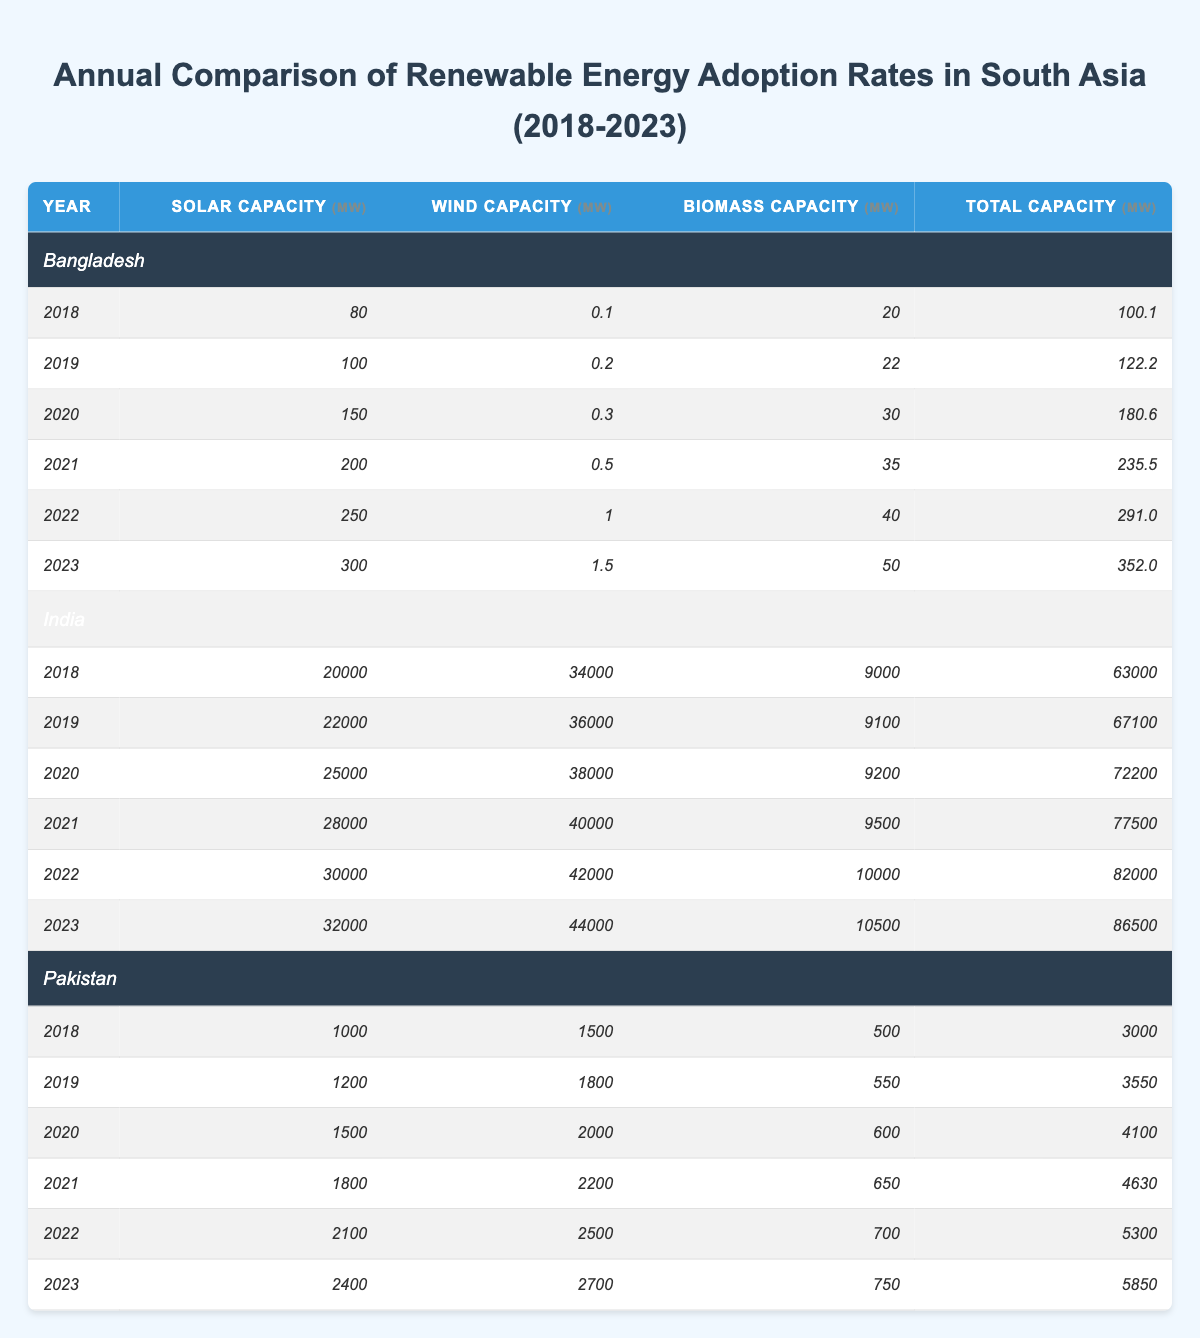What was the total renewable energy capacity in Bangladesh in 2023? The table shows that in 2023, Bangladesh had a total renewable energy capacity of 352.0 MW.
Answer: 352.0 MW Which country had the highest solar capacity in 2021? In 2021, the table indicates that India had the highest solar capacity with 28,000 MW, compared to Bangladesh's 200 MW and Pakistan's 1,800 MW.
Answer: India What is the difference in total renewable energy capacity between India in 2018 and in 2023? To find the difference, subtract India's total renewable energy capacity in 2018 (63,000 MW) from that in 2023 (86,500 MW): 86,500 - 63,000 = 23,500 MW.
Answer: 23,500 MW Is the biomass capacity in Pakistan greater in 2022 than in 2019? The table shows that Pakistan's biomass capacity was 700 MW in 2022 and 550 MW in 2019, so 700 is greater than 550.
Answer: Yes What was the average solar capacity for Bangladesh from 2018 to 2023? To compute the average, first sum the solar capacities: 80 + 100 + 150 + 200 + 250 + 300 = 1080 MW. Then, divide by the number of years, which is 6; 1080 / 6 = 180 MW.
Answer: 180 MW In which year did Pakistan first exceed a total capacity of 4000 MW? By examining the table, Pakistan first exceeded 4000 MW in 2020, with a total capacity of 4100 MW, while it was below that in previous years.
Answer: 2020 What is the ratio of India's wind capacity to Bangladesh's wind capacity in 2023? India's wind capacity in 2023 is 44,000 MW and Bangladesh's is 1.5 MW. To find the ratio: 44,000 / 1.5 = 29,333.33.
Answer: 29,333.33 How much did Bangladesh's total renewable energy capacity increase from 2022 to 2023? The total renewable energy capacity in Bangladesh for 2022 was 291.0 MW. For 2023, it was 352.0 MW. The increase is calculated as 352.0 - 291.0 = 61.0 MW.
Answer: 61.0 MW What was the total combined capacity of renewable energy for all three countries in 2023? From the table, in 2023, Bangladesh had 352.0 MW, India had 86,500 MW, and Pakistan had 5,850 MW. The total is: 352.0 + 86,500 + 5,850 = 92,702 MW.
Answer: 92,702 MW Was there a consistent increase in solar capacity in Bangladesh over the years? Examining the table, we see an increase in solar capacity every year, starting from 80 MW in 2018 up to 300 MW in 2023. Thus, there was consistent growth.
Answer: Yes 